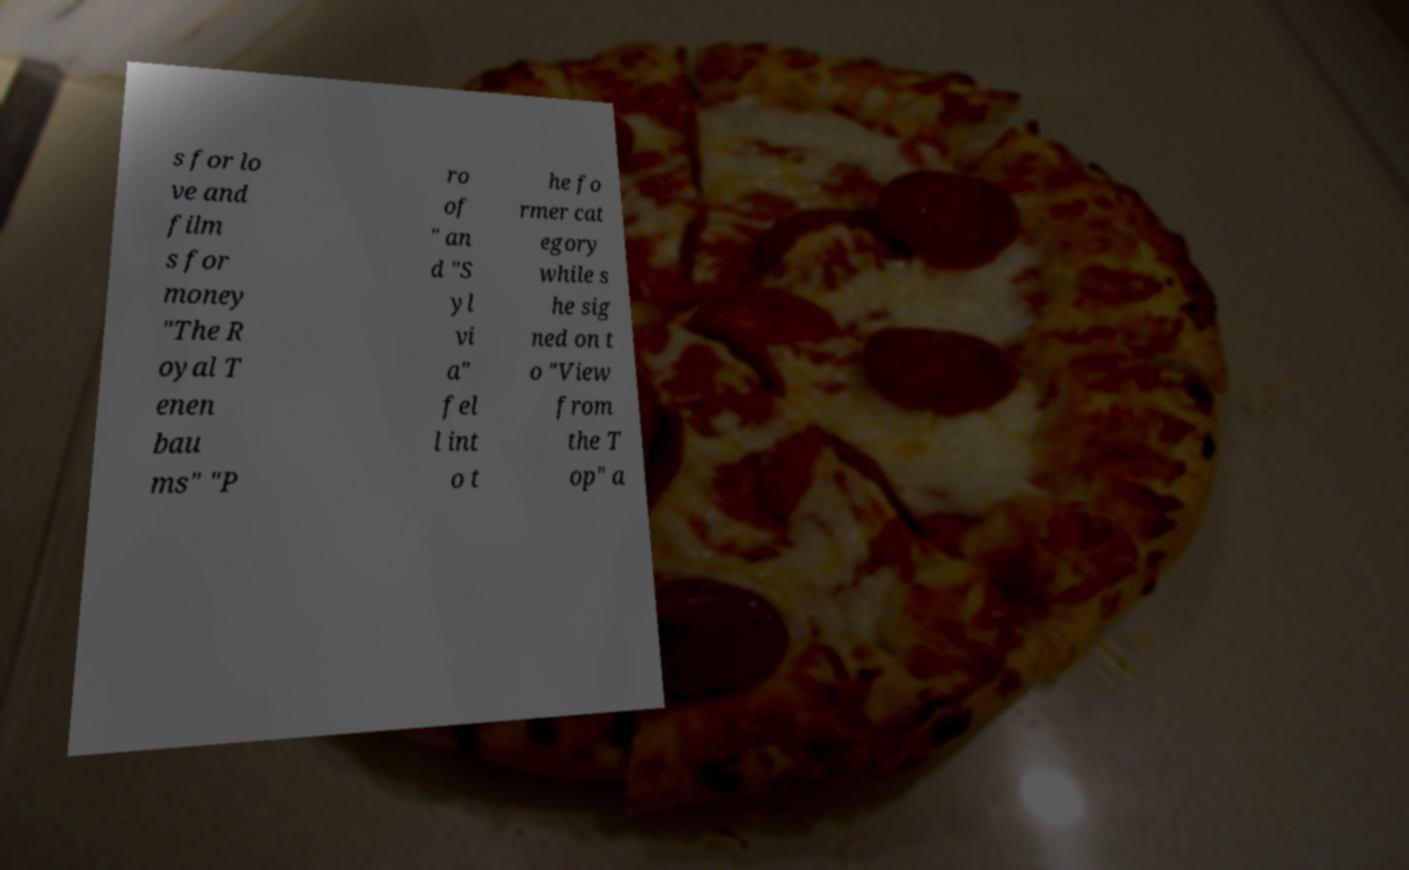Could you assist in decoding the text presented in this image and type it out clearly? s for lo ve and film s for money "The R oyal T enen bau ms" "P ro of " an d "S yl vi a" fel l int o t he fo rmer cat egory while s he sig ned on t o "View from the T op" a 